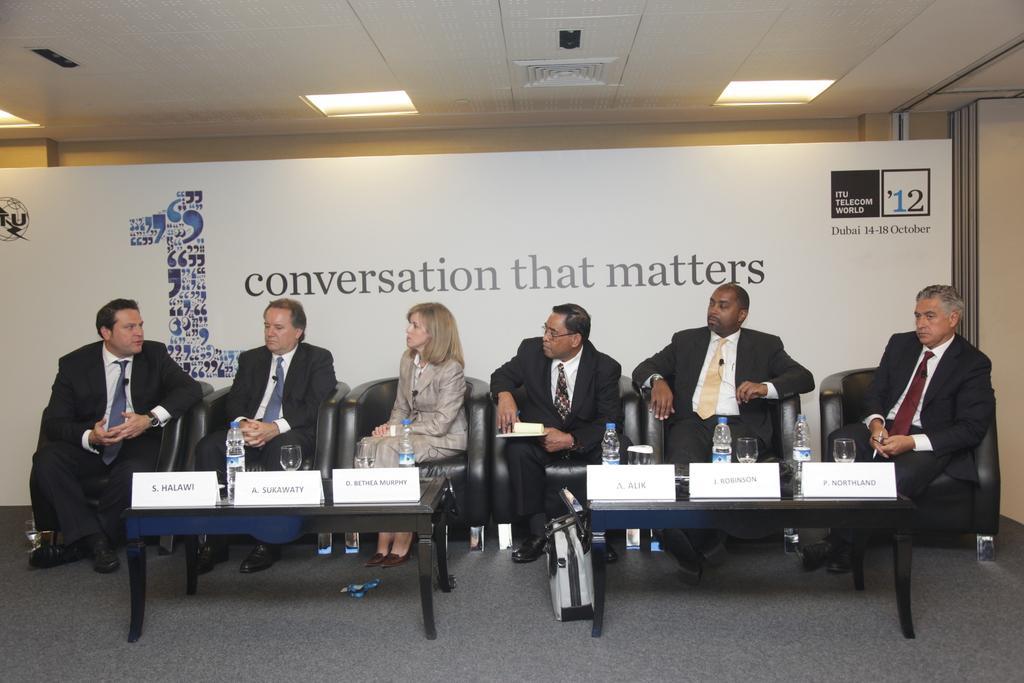Describe this image in one or two sentences. This is a picture where we can see six people one lady and five men among them sitting on sofas in front of table on which there are some glasses and behind them there is a board of white color and we can see some lights around the room. 